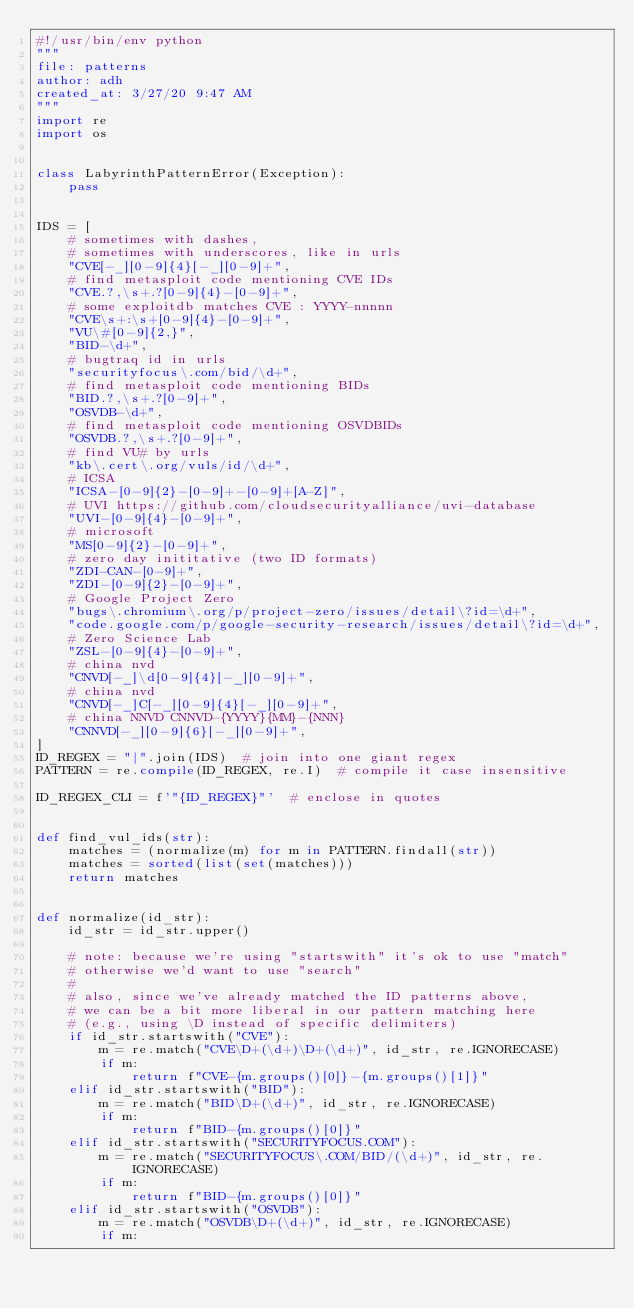Convert code to text. <code><loc_0><loc_0><loc_500><loc_500><_Python_>#!/usr/bin/env python
"""
file: patterns
author: adh
created_at: 3/27/20 9:47 AM
"""
import re
import os


class LabyrinthPatternError(Exception):
    pass


IDS = [
    # sometimes with dashes,
    # sometimes with underscores, like in urls
    "CVE[-_][0-9]{4}[-_][0-9]+",
    # find metasploit code mentioning CVE IDs
    "CVE.?,\s+.?[0-9]{4}-[0-9]+",
    # some exploitdb matches CVE : YYYY-nnnnn
    "CVE\s+:\s+[0-9]{4}-[0-9]+",
    "VU\#[0-9]{2,}",
    "BID-\d+",
    # bugtraq id in urls
    "securityfocus\.com/bid/\d+",
    # find metasploit code mentioning BIDs
    "BID.?,\s+.?[0-9]+",
    "OSVDB-\d+",
    # find metasploit code mentioning OSVDBIDs
    "OSVDB.?,\s+.?[0-9]+",
    # find VU# by urls
    "kb\.cert\.org/vuls/id/\d+",
    # ICSA
    "ICSA-[0-9]{2}-[0-9]+-[0-9]+[A-Z]",
    # UVI https://github.com/cloudsecurityalliance/uvi-database
    "UVI-[0-9]{4}-[0-9]+",
    # microsoft
    "MS[0-9]{2}-[0-9]+",
    # zero day inititative (two ID formats)
    "ZDI-CAN-[0-9]+",
    "ZDI-[0-9]{2}-[0-9]+",
    # Google Project Zero
    "bugs\.chromium\.org/p/project-zero/issues/detail\?id=\d+",
    "code.google.com/p/google-security-research/issues/detail\?id=\d+",
    # Zero Science Lab
    "ZSL-[0-9]{4}-[0-9]+",
    # china nvd
    "CNVD[-_]\d[0-9]{4}[-_][0-9]+",
    # china nvd
    "CNVD[-_]C[-_][0-9]{4}[-_][0-9]+",
    # china NNVD CNNVD-{YYYY}{MM}-{NNN}
    "CNNVD[-_][0-9]{6}[-_][0-9]+",
]
ID_REGEX = "|".join(IDS)  # join into one giant regex
PATTERN = re.compile(ID_REGEX, re.I)  # compile it case insensitive

ID_REGEX_CLI = f'"{ID_REGEX}"'  # enclose in quotes


def find_vul_ids(str):
    matches = (normalize(m) for m in PATTERN.findall(str))
    matches = sorted(list(set(matches)))
    return matches


def normalize(id_str):
    id_str = id_str.upper()

    # note: because we're using "startswith" it's ok to use "match"
    # otherwise we'd want to use "search"
    #
    # also, since we've already matched the ID patterns above,
    # we can be a bit more liberal in our pattern matching here
    # (e.g., using \D instead of specific delimiters)
    if id_str.startswith("CVE"):
        m = re.match("CVE\D+(\d+)\D+(\d+)", id_str, re.IGNORECASE)
        if m:
            return f"CVE-{m.groups()[0]}-{m.groups()[1]}"
    elif id_str.startswith("BID"):
        m = re.match("BID\D+(\d+)", id_str, re.IGNORECASE)
        if m:
            return f"BID-{m.groups()[0]}"
    elif id_str.startswith("SECURITYFOCUS.COM"):
        m = re.match("SECURITYFOCUS\.COM/BID/(\d+)", id_str, re.IGNORECASE)
        if m:
            return f"BID-{m.groups()[0]}"
    elif id_str.startswith("OSVDB"):
        m = re.match("OSVDB\D+(\d+)", id_str, re.IGNORECASE)
        if m:</code> 